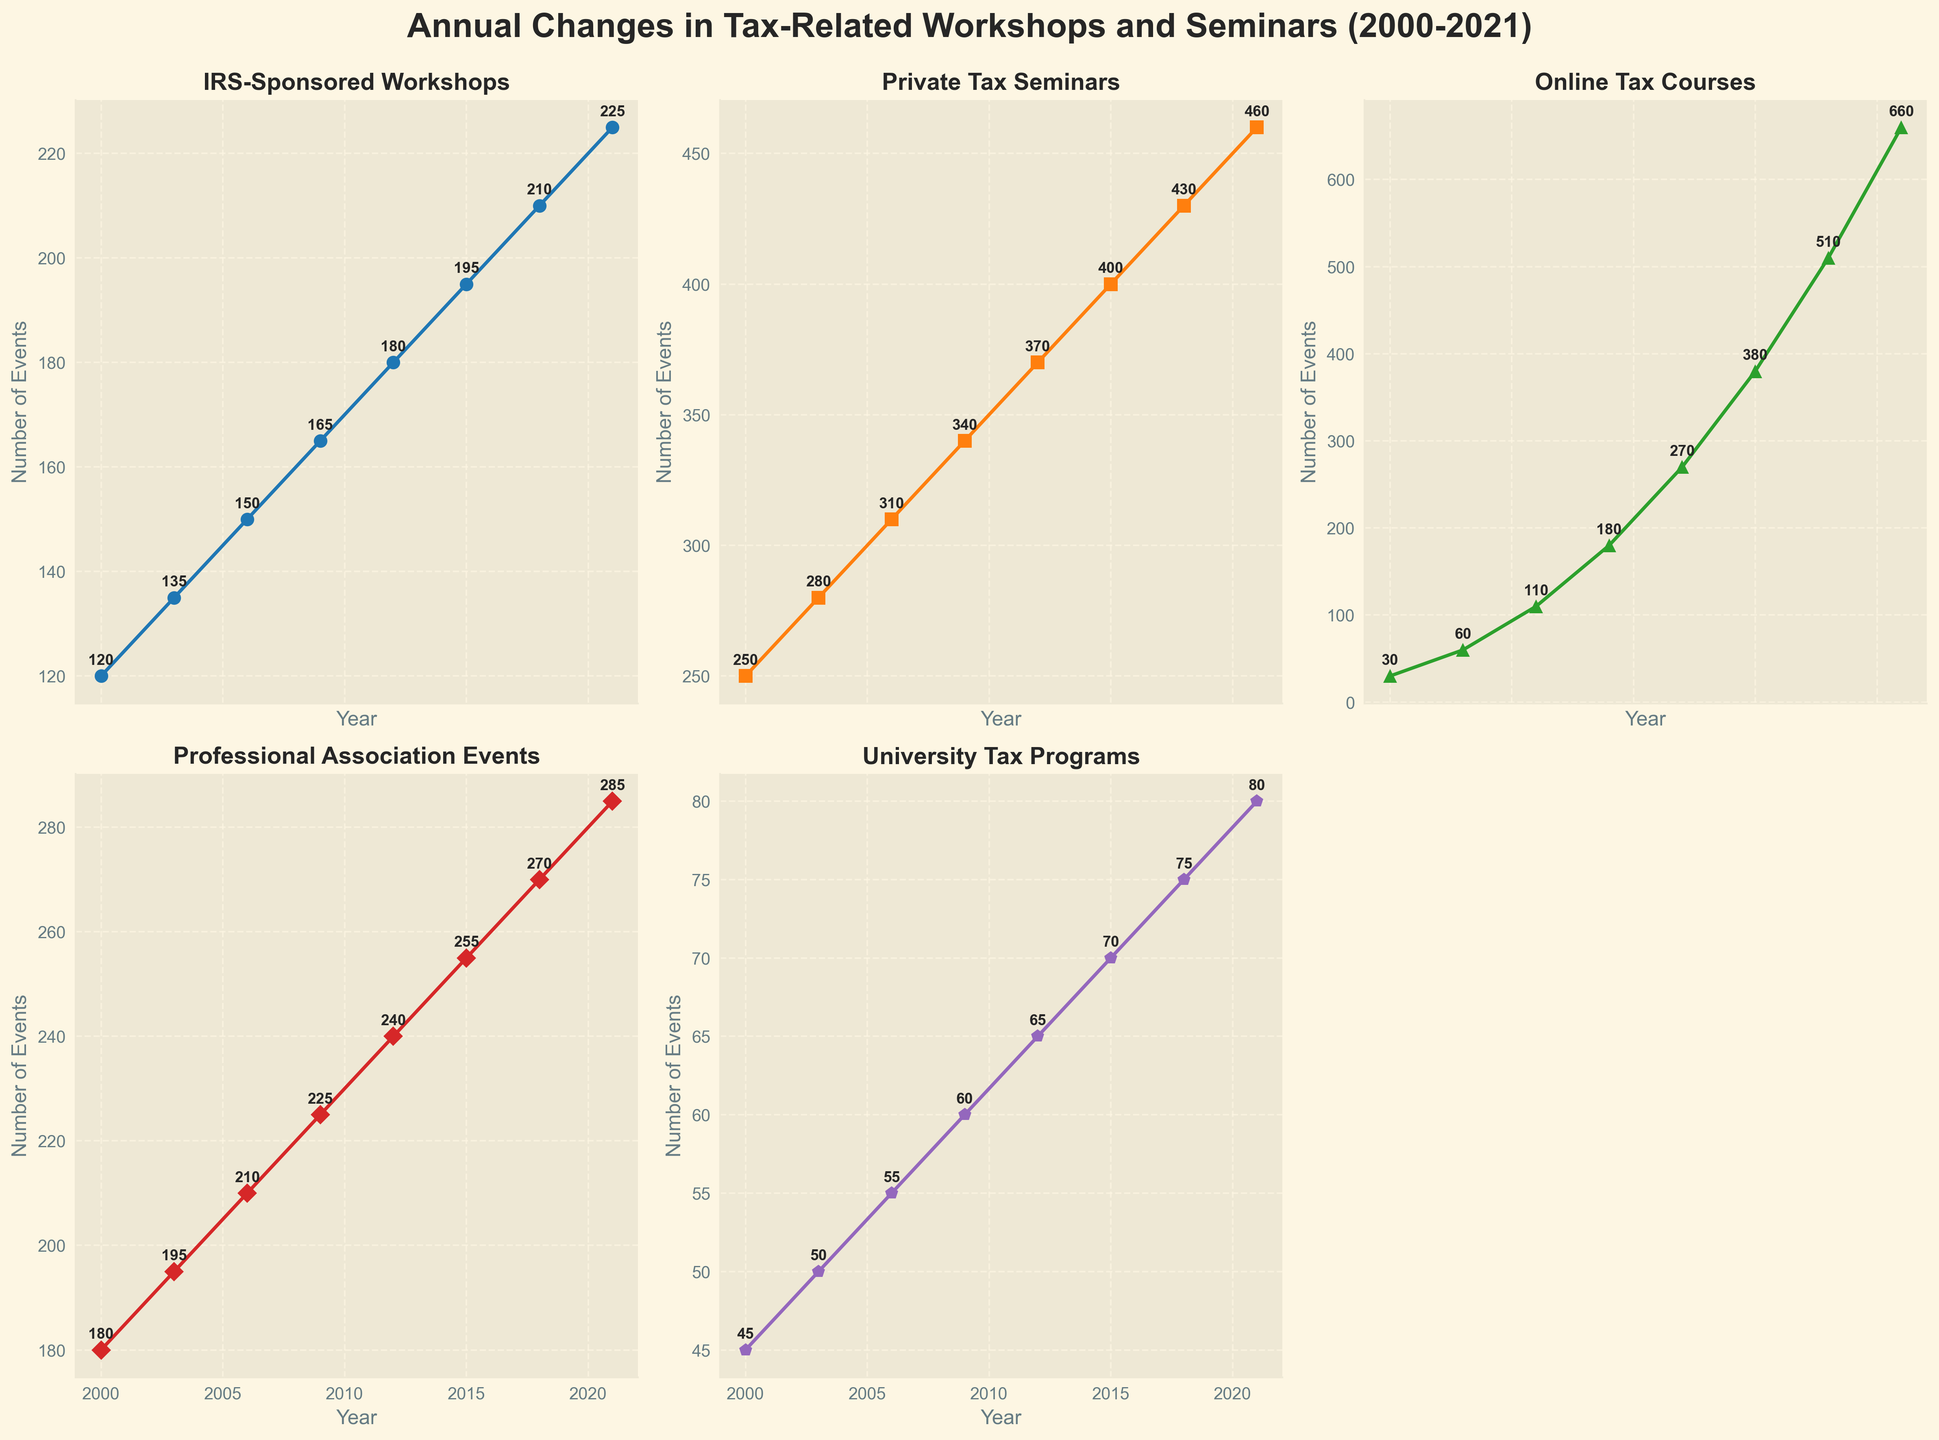what is the overall trend for IRS-Sponsored Workshops from 2000 to 2021? The trend for IRS-Sponsored Workshops can be identified by observing the line corresponding to this category. The line shows a continuous upward trend from 120 workshops in 2000 to 225 workshops in 2021.
Answer: Upward Which type of tax-related workshop or seminar had the highest growth rate from 2000 to 2021? To determine the highest growth rate, observe the steepest lines between 2000 and 2021. Online Tax Courses increased from 30 to 660, representing the highest growth among all the types.
Answer: Online Tax Courses In which year did Private Tax Seminars reach 400 events? To find this year, locate the point on the line for Private Tax Seminars where it intersects the value of 400. This point is in the year 2015.
Answer: 2015 How many University Tax Programs were offered in 2018? Look at the data point corresponding to the year 2018 on the University Tax Programs line. It shows 75 programs.
Answer: 75 Compare the number of Professional Association Events in 2000 and 2021; is there an increase or decrease and by how many? In 2000, the number of Professional Association Events was 180, and in 2021, it was 285. The difference is 285 - 180 = 105, showing an increase of 105 events.
Answer: Increase by 105 Which category had the lowest number of events in 2003? Identify the category with the smallest number by comparing the data points for the year 2003. Online Tax Courses had the lowest number with 60 events.
Answer: Online Tax Courses What is the average number of Online Tax Courses offered annually from 2000 to 2021? Sum the values for Online Tax Courses from all the years (30, 60, 110, 180, 270, 380, 510, 660) which gives a total of 2200. Divide this sum by the 8 years provided, resulting in an average of 275.
Answer: 275 In which year did all categories show an increase compared to the previous period? By observing the progression of lines in each subplot, note that from 2009 to 2012, all shows a noticeable increase in data points: IRS-Sponsored Workshops (165 to 180), Private Tax Seminars (340 to 370), Online Tax Courses (180 to 270), Professional Association Events (225 to 240), and University Tax Programs (60 to 65).
Answer: 2012 What is the largest number of Professional Association Events observed and in which year? By identifying the peak value on the line for Professional Association Events, 285 events are found in the year 2021.
Answer: 285 in 2021 